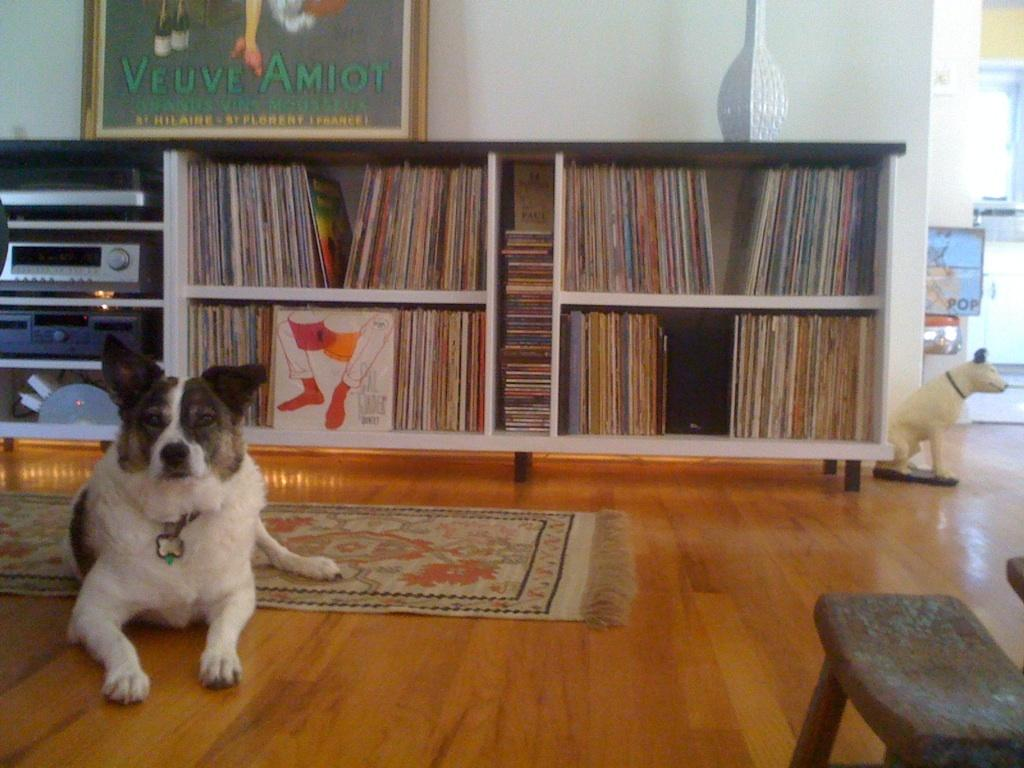What can be seen in the rack in the image? There are many books in the rack in the image. What electronic device is present on the left side in the image? There is a music player on the left side in the image. What is the dog doing in the image? There is a dog laying on the wooden floor in the front of the image. What type of decorative item is on the right side in the image? There is a dog statue on the right side in the image. What type of cushion is present in the image? There is no cushion present in the image. What type of library is shown in the image? The image does not depict a library; it shows a room with a book rack, music player, and dogs. 